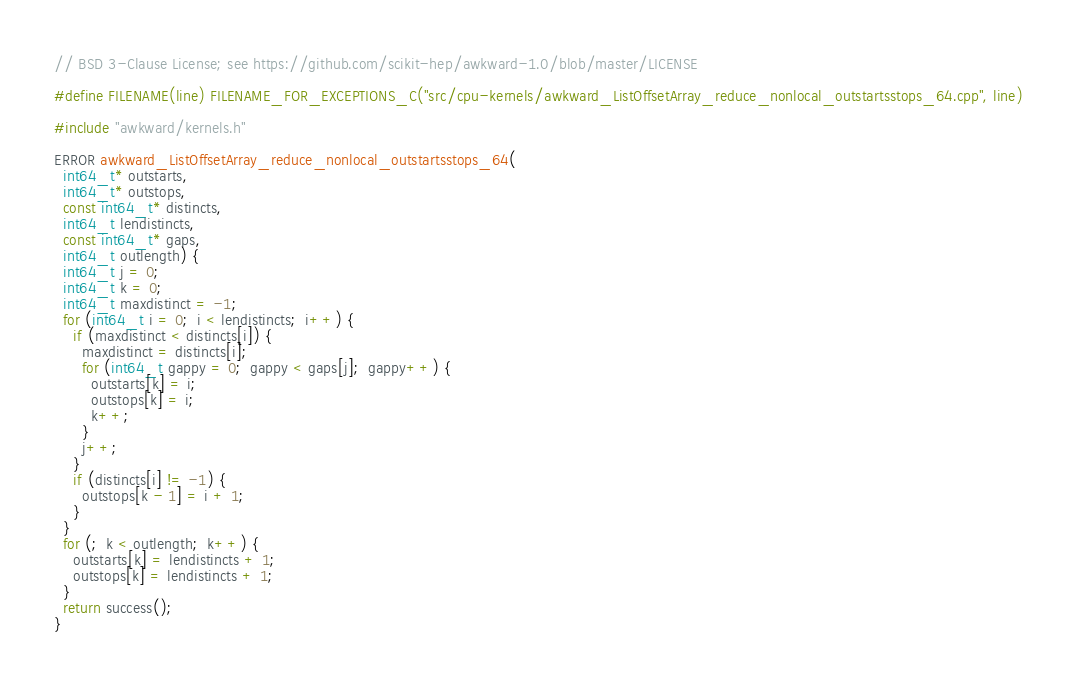<code> <loc_0><loc_0><loc_500><loc_500><_C++_>// BSD 3-Clause License; see https://github.com/scikit-hep/awkward-1.0/blob/master/LICENSE

#define FILENAME(line) FILENAME_FOR_EXCEPTIONS_C("src/cpu-kernels/awkward_ListOffsetArray_reduce_nonlocal_outstartsstops_64.cpp", line)

#include "awkward/kernels.h"

ERROR awkward_ListOffsetArray_reduce_nonlocal_outstartsstops_64(
  int64_t* outstarts,
  int64_t* outstops,
  const int64_t* distincts,
  int64_t lendistincts,
  const int64_t* gaps,
  int64_t outlength) {
  int64_t j = 0;
  int64_t k = 0;
  int64_t maxdistinct = -1;
  for (int64_t i = 0;  i < lendistincts;  i++) {
    if (maxdistinct < distincts[i]) {
      maxdistinct = distincts[i];
      for (int64_t gappy = 0;  gappy < gaps[j];  gappy++) {
        outstarts[k] = i;
        outstops[k] = i;
        k++;
      }
      j++;
    }
    if (distincts[i] != -1) {
      outstops[k - 1] = i + 1;
    }
  }
  for (;  k < outlength;  k++) {
    outstarts[k] = lendistincts + 1;
    outstops[k] = lendistincts + 1;
  }
  return success();
}
</code> 